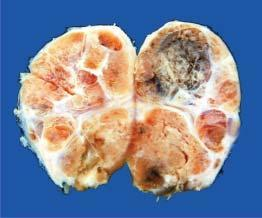s the thyroid gland enlarged and nodular?
Answer the question using a single word or phrase. Yes 